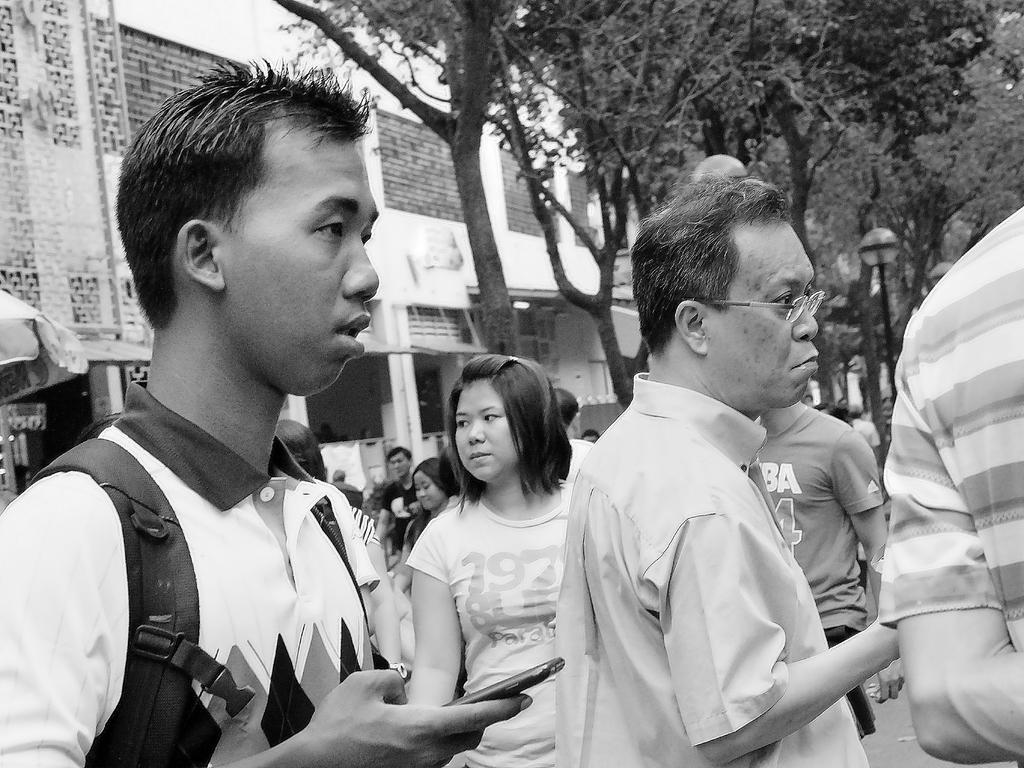What can be seen in the foreground of the image? There are people standing in the front of the image. What type of natural elements are visible in the background of the image? There are trees in the background of the image. What man-made structures can be seen in the background of the image? There are buildings and a pole in the background of the image. What is the color scheme of the image? The image is black and white. Is there a roof visible in the image? There is no roof mentioned or visible in the image. Does the wind have any effect on the people standing in the image? The image is in black and white, and there is no indication of wind or its effects on the people in the image. 